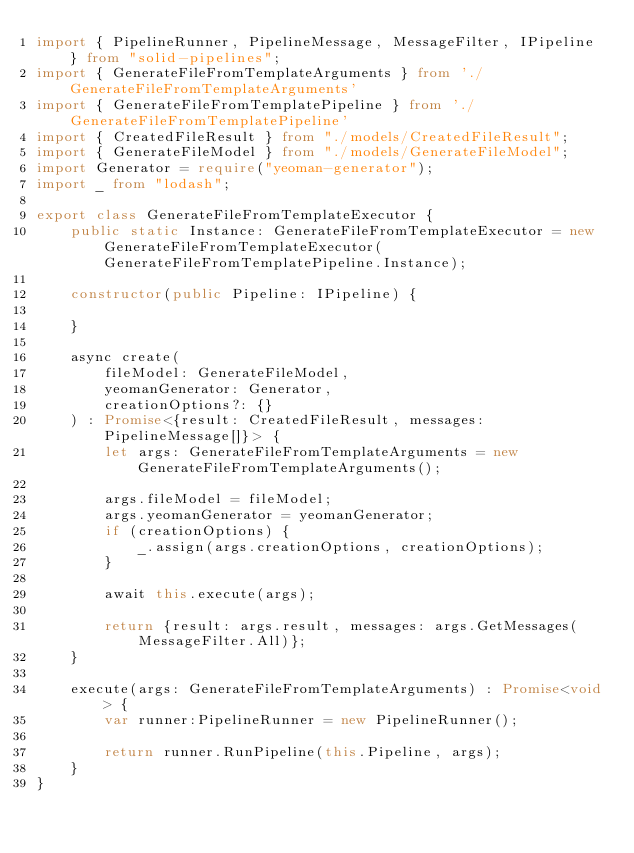Convert code to text. <code><loc_0><loc_0><loc_500><loc_500><_TypeScript_>import { PipelineRunner, PipelineMessage, MessageFilter, IPipeline } from "solid-pipelines";
import { GenerateFileFromTemplateArguments } from './GenerateFileFromTemplateArguments'
import { GenerateFileFromTemplatePipeline } from './GenerateFileFromTemplatePipeline'
import { CreatedFileResult } from "./models/CreatedFileResult";
import { GenerateFileModel } from "./models/GenerateFileModel";
import Generator = require("yeoman-generator");
import _ from "lodash";

export class GenerateFileFromTemplateExecutor {
    public static Instance: GenerateFileFromTemplateExecutor = new GenerateFileFromTemplateExecutor(GenerateFileFromTemplatePipeline.Instance);

    constructor(public Pipeline: IPipeline) {
        
    }

    async create(
        fileModel: GenerateFileModel,
        yeomanGenerator: Generator,
        creationOptions?: {}
    ) : Promise<{result: CreatedFileResult, messages: PipelineMessage[]}> {
        let args: GenerateFileFromTemplateArguments = new GenerateFileFromTemplateArguments();

        args.fileModel = fileModel;
        args.yeomanGenerator = yeomanGenerator;
        if (creationOptions) {
            _.assign(args.creationOptions, creationOptions);
        }
        
        await this.execute(args);

        return {result: args.result, messages: args.GetMessages(MessageFilter.All)};
    }

    execute(args: GenerateFileFromTemplateArguments) : Promise<void> {
        var runner:PipelineRunner = new PipelineRunner();

        return runner.RunPipeline(this.Pipeline, args);
    }
}</code> 